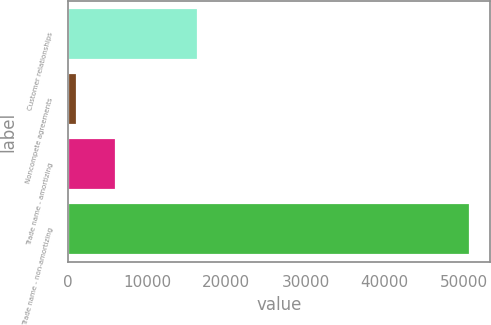Convert chart. <chart><loc_0><loc_0><loc_500><loc_500><bar_chart><fcel>Customer relationships<fcel>Noncompete agreements<fcel>Trade name - amortizing<fcel>Trade name - non-amortizing<nl><fcel>16415<fcel>1193<fcel>6150.6<fcel>50769<nl></chart> 